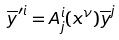<formula> <loc_0><loc_0><loc_500><loc_500>\overline { y } ^ { \prime i } = A _ { j } ^ { i } ( x ^ { \nu } ) \overline { y } ^ { j }</formula> 